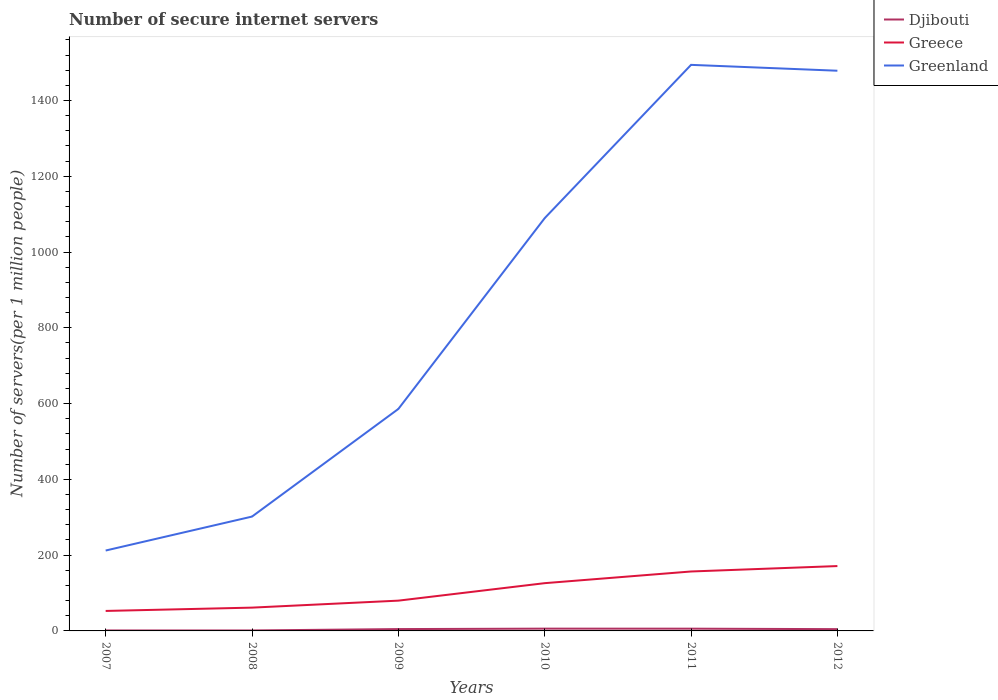Across all years, what is the maximum number of secure internet servers in Greenland?
Offer a very short reply. 212.18. What is the total number of secure internet servers in Greece in the graph?
Your answer should be very brief. -64.56. What is the difference between the highest and the second highest number of secure internet servers in Greece?
Provide a succinct answer. 118.43. What is the difference between the highest and the lowest number of secure internet servers in Greenland?
Your answer should be very brief. 3. Are the values on the major ticks of Y-axis written in scientific E-notation?
Give a very brief answer. No. How many legend labels are there?
Give a very brief answer. 3. How are the legend labels stacked?
Provide a short and direct response. Vertical. What is the title of the graph?
Provide a short and direct response. Number of secure internet servers. What is the label or title of the Y-axis?
Provide a short and direct response. Number of servers(per 1 million people). What is the Number of servers(per 1 million people) of Djibouti in 2007?
Your answer should be compact. 1.25. What is the Number of servers(per 1 million people) in Greece in 2007?
Your answer should be compact. 52.76. What is the Number of servers(per 1 million people) in Greenland in 2007?
Provide a succinct answer. 212.18. What is the Number of servers(per 1 million people) in Djibouti in 2008?
Make the answer very short. 1.24. What is the Number of servers(per 1 million people) in Greece in 2008?
Keep it short and to the point. 61.5. What is the Number of servers(per 1 million people) in Greenland in 2008?
Ensure brevity in your answer.  301.8. What is the Number of servers(per 1 million people) of Djibouti in 2009?
Give a very brief answer. 4.88. What is the Number of servers(per 1 million people) of Greece in 2009?
Keep it short and to the point. 79.91. What is the Number of servers(per 1 million people) in Greenland in 2009?
Offer a terse response. 585.91. What is the Number of servers(per 1 million people) of Djibouti in 2010?
Give a very brief answer. 6.02. What is the Number of servers(per 1 million people) in Greece in 2010?
Keep it short and to the point. 126.06. What is the Number of servers(per 1 million people) in Greenland in 2010?
Provide a short and direct response. 1089.54. What is the Number of servers(per 1 million people) in Djibouti in 2011?
Give a very brief answer. 5.94. What is the Number of servers(per 1 million people) in Greece in 2011?
Your response must be concise. 156.88. What is the Number of servers(per 1 million people) in Greenland in 2011?
Make the answer very short. 1494.11. What is the Number of servers(per 1 million people) in Djibouti in 2012?
Offer a very short reply. 4.69. What is the Number of servers(per 1 million people) of Greece in 2012?
Provide a succinct answer. 171.19. What is the Number of servers(per 1 million people) in Greenland in 2012?
Offer a very short reply. 1478.61. Across all years, what is the maximum Number of servers(per 1 million people) in Djibouti?
Offer a terse response. 6.02. Across all years, what is the maximum Number of servers(per 1 million people) of Greece?
Your answer should be compact. 171.19. Across all years, what is the maximum Number of servers(per 1 million people) of Greenland?
Provide a short and direct response. 1494.11. Across all years, what is the minimum Number of servers(per 1 million people) in Djibouti?
Your response must be concise. 1.24. Across all years, what is the minimum Number of servers(per 1 million people) in Greece?
Offer a terse response. 52.76. Across all years, what is the minimum Number of servers(per 1 million people) in Greenland?
Offer a terse response. 212.18. What is the total Number of servers(per 1 million people) in Djibouti in the graph?
Keep it short and to the point. 24.01. What is the total Number of servers(per 1 million people) in Greece in the graph?
Keep it short and to the point. 648.31. What is the total Number of servers(per 1 million people) in Greenland in the graph?
Keep it short and to the point. 5162.15. What is the difference between the Number of servers(per 1 million people) in Djibouti in 2007 and that in 2008?
Provide a short and direct response. 0.02. What is the difference between the Number of servers(per 1 million people) of Greece in 2007 and that in 2008?
Provide a succinct answer. -8.74. What is the difference between the Number of servers(per 1 million people) of Greenland in 2007 and that in 2008?
Your answer should be very brief. -89.62. What is the difference between the Number of servers(per 1 million people) in Djibouti in 2007 and that in 2009?
Your response must be concise. -3.63. What is the difference between the Number of servers(per 1 million people) of Greece in 2007 and that in 2009?
Provide a short and direct response. -27.15. What is the difference between the Number of servers(per 1 million people) of Greenland in 2007 and that in 2009?
Provide a succinct answer. -373.72. What is the difference between the Number of servers(per 1 million people) in Djibouti in 2007 and that in 2010?
Make the answer very short. -4.77. What is the difference between the Number of servers(per 1 million people) of Greece in 2007 and that in 2010?
Offer a terse response. -73.3. What is the difference between the Number of servers(per 1 million people) of Greenland in 2007 and that in 2010?
Your answer should be very brief. -877.35. What is the difference between the Number of servers(per 1 million people) in Djibouti in 2007 and that in 2011?
Offer a very short reply. -4.69. What is the difference between the Number of servers(per 1 million people) in Greece in 2007 and that in 2011?
Your answer should be compact. -104.12. What is the difference between the Number of servers(per 1 million people) of Greenland in 2007 and that in 2011?
Ensure brevity in your answer.  -1281.93. What is the difference between the Number of servers(per 1 million people) in Djibouti in 2007 and that in 2012?
Keep it short and to the point. -3.44. What is the difference between the Number of servers(per 1 million people) of Greece in 2007 and that in 2012?
Give a very brief answer. -118.43. What is the difference between the Number of servers(per 1 million people) of Greenland in 2007 and that in 2012?
Your response must be concise. -1266.43. What is the difference between the Number of servers(per 1 million people) in Djibouti in 2008 and that in 2009?
Your answer should be compact. -3.64. What is the difference between the Number of servers(per 1 million people) of Greece in 2008 and that in 2009?
Offer a terse response. -18.41. What is the difference between the Number of servers(per 1 million people) of Greenland in 2008 and that in 2009?
Your answer should be very brief. -284.1. What is the difference between the Number of servers(per 1 million people) of Djibouti in 2008 and that in 2010?
Your answer should be very brief. -4.78. What is the difference between the Number of servers(per 1 million people) in Greece in 2008 and that in 2010?
Your answer should be compact. -64.56. What is the difference between the Number of servers(per 1 million people) of Greenland in 2008 and that in 2010?
Offer a very short reply. -787.73. What is the difference between the Number of servers(per 1 million people) in Djibouti in 2008 and that in 2011?
Give a very brief answer. -4.7. What is the difference between the Number of servers(per 1 million people) of Greece in 2008 and that in 2011?
Offer a very short reply. -95.38. What is the difference between the Number of servers(per 1 million people) of Greenland in 2008 and that in 2011?
Provide a short and direct response. -1192.31. What is the difference between the Number of servers(per 1 million people) in Djibouti in 2008 and that in 2012?
Provide a short and direct response. -3.45. What is the difference between the Number of servers(per 1 million people) in Greece in 2008 and that in 2012?
Offer a terse response. -109.69. What is the difference between the Number of servers(per 1 million people) in Greenland in 2008 and that in 2012?
Ensure brevity in your answer.  -1176.81. What is the difference between the Number of servers(per 1 million people) in Djibouti in 2009 and that in 2010?
Ensure brevity in your answer.  -1.14. What is the difference between the Number of servers(per 1 million people) of Greece in 2009 and that in 2010?
Ensure brevity in your answer.  -46.15. What is the difference between the Number of servers(per 1 million people) of Greenland in 2009 and that in 2010?
Ensure brevity in your answer.  -503.63. What is the difference between the Number of servers(per 1 million people) in Djibouti in 2009 and that in 2011?
Offer a terse response. -1.06. What is the difference between the Number of servers(per 1 million people) in Greece in 2009 and that in 2011?
Your answer should be compact. -76.97. What is the difference between the Number of servers(per 1 million people) in Greenland in 2009 and that in 2011?
Make the answer very short. -908.21. What is the difference between the Number of servers(per 1 million people) in Djibouti in 2009 and that in 2012?
Make the answer very short. 0.19. What is the difference between the Number of servers(per 1 million people) of Greece in 2009 and that in 2012?
Your answer should be very brief. -91.28. What is the difference between the Number of servers(per 1 million people) of Greenland in 2009 and that in 2012?
Make the answer very short. -892.71. What is the difference between the Number of servers(per 1 million people) in Djibouti in 2010 and that in 2011?
Offer a very short reply. 0.08. What is the difference between the Number of servers(per 1 million people) of Greece in 2010 and that in 2011?
Your answer should be compact. -30.82. What is the difference between the Number of servers(per 1 million people) in Greenland in 2010 and that in 2011?
Provide a succinct answer. -404.58. What is the difference between the Number of servers(per 1 million people) of Djibouti in 2010 and that in 2012?
Give a very brief answer. 1.33. What is the difference between the Number of servers(per 1 million people) in Greece in 2010 and that in 2012?
Give a very brief answer. -45.13. What is the difference between the Number of servers(per 1 million people) of Greenland in 2010 and that in 2012?
Give a very brief answer. -389.08. What is the difference between the Number of servers(per 1 million people) in Djibouti in 2011 and that in 2012?
Ensure brevity in your answer.  1.25. What is the difference between the Number of servers(per 1 million people) in Greece in 2011 and that in 2012?
Your answer should be compact. -14.31. What is the difference between the Number of servers(per 1 million people) in Greenland in 2011 and that in 2012?
Provide a short and direct response. 15.5. What is the difference between the Number of servers(per 1 million people) in Djibouti in 2007 and the Number of servers(per 1 million people) in Greece in 2008?
Provide a short and direct response. -60.25. What is the difference between the Number of servers(per 1 million people) in Djibouti in 2007 and the Number of servers(per 1 million people) in Greenland in 2008?
Keep it short and to the point. -300.55. What is the difference between the Number of servers(per 1 million people) of Greece in 2007 and the Number of servers(per 1 million people) of Greenland in 2008?
Your answer should be compact. -249.04. What is the difference between the Number of servers(per 1 million people) of Djibouti in 2007 and the Number of servers(per 1 million people) of Greece in 2009?
Provide a short and direct response. -78.66. What is the difference between the Number of servers(per 1 million people) of Djibouti in 2007 and the Number of servers(per 1 million people) of Greenland in 2009?
Your answer should be very brief. -584.66. What is the difference between the Number of servers(per 1 million people) of Greece in 2007 and the Number of servers(per 1 million people) of Greenland in 2009?
Keep it short and to the point. -533.14. What is the difference between the Number of servers(per 1 million people) in Djibouti in 2007 and the Number of servers(per 1 million people) in Greece in 2010?
Your response must be concise. -124.81. What is the difference between the Number of servers(per 1 million people) of Djibouti in 2007 and the Number of servers(per 1 million people) of Greenland in 2010?
Provide a short and direct response. -1088.28. What is the difference between the Number of servers(per 1 million people) in Greece in 2007 and the Number of servers(per 1 million people) in Greenland in 2010?
Provide a succinct answer. -1036.77. What is the difference between the Number of servers(per 1 million people) of Djibouti in 2007 and the Number of servers(per 1 million people) of Greece in 2011?
Keep it short and to the point. -155.63. What is the difference between the Number of servers(per 1 million people) of Djibouti in 2007 and the Number of servers(per 1 million people) of Greenland in 2011?
Keep it short and to the point. -1492.86. What is the difference between the Number of servers(per 1 million people) in Greece in 2007 and the Number of servers(per 1 million people) in Greenland in 2011?
Offer a very short reply. -1441.35. What is the difference between the Number of servers(per 1 million people) in Djibouti in 2007 and the Number of servers(per 1 million people) in Greece in 2012?
Offer a very short reply. -169.94. What is the difference between the Number of servers(per 1 million people) of Djibouti in 2007 and the Number of servers(per 1 million people) of Greenland in 2012?
Provide a succinct answer. -1477.36. What is the difference between the Number of servers(per 1 million people) of Greece in 2007 and the Number of servers(per 1 million people) of Greenland in 2012?
Keep it short and to the point. -1425.85. What is the difference between the Number of servers(per 1 million people) in Djibouti in 2008 and the Number of servers(per 1 million people) in Greece in 2009?
Make the answer very short. -78.68. What is the difference between the Number of servers(per 1 million people) in Djibouti in 2008 and the Number of servers(per 1 million people) in Greenland in 2009?
Provide a short and direct response. -584.67. What is the difference between the Number of servers(per 1 million people) of Greece in 2008 and the Number of servers(per 1 million people) of Greenland in 2009?
Ensure brevity in your answer.  -524.4. What is the difference between the Number of servers(per 1 million people) in Djibouti in 2008 and the Number of servers(per 1 million people) in Greece in 2010?
Ensure brevity in your answer.  -124.82. What is the difference between the Number of servers(per 1 million people) of Djibouti in 2008 and the Number of servers(per 1 million people) of Greenland in 2010?
Make the answer very short. -1088.3. What is the difference between the Number of servers(per 1 million people) of Greece in 2008 and the Number of servers(per 1 million people) of Greenland in 2010?
Your answer should be compact. -1028.03. What is the difference between the Number of servers(per 1 million people) in Djibouti in 2008 and the Number of servers(per 1 million people) in Greece in 2011?
Offer a terse response. -155.64. What is the difference between the Number of servers(per 1 million people) of Djibouti in 2008 and the Number of servers(per 1 million people) of Greenland in 2011?
Keep it short and to the point. -1492.88. What is the difference between the Number of servers(per 1 million people) in Greece in 2008 and the Number of servers(per 1 million people) in Greenland in 2011?
Your response must be concise. -1432.61. What is the difference between the Number of servers(per 1 million people) of Djibouti in 2008 and the Number of servers(per 1 million people) of Greece in 2012?
Your response must be concise. -169.96. What is the difference between the Number of servers(per 1 million people) in Djibouti in 2008 and the Number of servers(per 1 million people) in Greenland in 2012?
Make the answer very short. -1477.38. What is the difference between the Number of servers(per 1 million people) of Greece in 2008 and the Number of servers(per 1 million people) of Greenland in 2012?
Keep it short and to the point. -1417.11. What is the difference between the Number of servers(per 1 million people) in Djibouti in 2009 and the Number of servers(per 1 million people) in Greece in 2010?
Ensure brevity in your answer.  -121.18. What is the difference between the Number of servers(per 1 million people) of Djibouti in 2009 and the Number of servers(per 1 million people) of Greenland in 2010?
Give a very brief answer. -1084.66. What is the difference between the Number of servers(per 1 million people) of Greece in 2009 and the Number of servers(per 1 million people) of Greenland in 2010?
Make the answer very short. -1009.62. What is the difference between the Number of servers(per 1 million people) of Djibouti in 2009 and the Number of servers(per 1 million people) of Greece in 2011?
Provide a succinct answer. -152. What is the difference between the Number of servers(per 1 million people) of Djibouti in 2009 and the Number of servers(per 1 million people) of Greenland in 2011?
Provide a short and direct response. -1489.23. What is the difference between the Number of servers(per 1 million people) of Greece in 2009 and the Number of servers(per 1 million people) of Greenland in 2011?
Ensure brevity in your answer.  -1414.2. What is the difference between the Number of servers(per 1 million people) of Djibouti in 2009 and the Number of servers(per 1 million people) of Greece in 2012?
Make the answer very short. -166.32. What is the difference between the Number of servers(per 1 million people) in Djibouti in 2009 and the Number of servers(per 1 million people) in Greenland in 2012?
Offer a very short reply. -1473.74. What is the difference between the Number of servers(per 1 million people) of Greece in 2009 and the Number of servers(per 1 million people) of Greenland in 2012?
Offer a very short reply. -1398.7. What is the difference between the Number of servers(per 1 million people) in Djibouti in 2010 and the Number of servers(per 1 million people) in Greece in 2011?
Provide a short and direct response. -150.86. What is the difference between the Number of servers(per 1 million people) of Djibouti in 2010 and the Number of servers(per 1 million people) of Greenland in 2011?
Offer a very short reply. -1488.09. What is the difference between the Number of servers(per 1 million people) in Greece in 2010 and the Number of servers(per 1 million people) in Greenland in 2011?
Your answer should be compact. -1368.05. What is the difference between the Number of servers(per 1 million people) of Djibouti in 2010 and the Number of servers(per 1 million people) of Greece in 2012?
Provide a short and direct response. -165.17. What is the difference between the Number of servers(per 1 million people) in Djibouti in 2010 and the Number of servers(per 1 million people) in Greenland in 2012?
Your answer should be compact. -1472.59. What is the difference between the Number of servers(per 1 million people) of Greece in 2010 and the Number of servers(per 1 million people) of Greenland in 2012?
Your answer should be compact. -1352.55. What is the difference between the Number of servers(per 1 million people) in Djibouti in 2011 and the Number of servers(per 1 million people) in Greece in 2012?
Offer a very short reply. -165.25. What is the difference between the Number of servers(per 1 million people) of Djibouti in 2011 and the Number of servers(per 1 million people) of Greenland in 2012?
Provide a succinct answer. -1472.67. What is the difference between the Number of servers(per 1 million people) of Greece in 2011 and the Number of servers(per 1 million people) of Greenland in 2012?
Provide a short and direct response. -1321.73. What is the average Number of servers(per 1 million people) in Djibouti per year?
Your answer should be very brief. 4. What is the average Number of servers(per 1 million people) of Greece per year?
Provide a succinct answer. 108.05. What is the average Number of servers(per 1 million people) in Greenland per year?
Provide a short and direct response. 860.36. In the year 2007, what is the difference between the Number of servers(per 1 million people) of Djibouti and Number of servers(per 1 million people) of Greece?
Provide a succinct answer. -51.51. In the year 2007, what is the difference between the Number of servers(per 1 million people) in Djibouti and Number of servers(per 1 million people) in Greenland?
Your answer should be very brief. -210.93. In the year 2007, what is the difference between the Number of servers(per 1 million people) of Greece and Number of servers(per 1 million people) of Greenland?
Your answer should be very brief. -159.42. In the year 2008, what is the difference between the Number of servers(per 1 million people) of Djibouti and Number of servers(per 1 million people) of Greece?
Provide a short and direct response. -60.27. In the year 2008, what is the difference between the Number of servers(per 1 million people) in Djibouti and Number of servers(per 1 million people) in Greenland?
Offer a terse response. -300.57. In the year 2008, what is the difference between the Number of servers(per 1 million people) in Greece and Number of servers(per 1 million people) in Greenland?
Your response must be concise. -240.3. In the year 2009, what is the difference between the Number of servers(per 1 million people) in Djibouti and Number of servers(per 1 million people) in Greece?
Your answer should be compact. -75.04. In the year 2009, what is the difference between the Number of servers(per 1 million people) of Djibouti and Number of servers(per 1 million people) of Greenland?
Your response must be concise. -581.03. In the year 2009, what is the difference between the Number of servers(per 1 million people) of Greece and Number of servers(per 1 million people) of Greenland?
Provide a succinct answer. -505.99. In the year 2010, what is the difference between the Number of servers(per 1 million people) in Djibouti and Number of servers(per 1 million people) in Greece?
Make the answer very short. -120.04. In the year 2010, what is the difference between the Number of servers(per 1 million people) of Djibouti and Number of servers(per 1 million people) of Greenland?
Provide a short and direct response. -1083.52. In the year 2010, what is the difference between the Number of servers(per 1 million people) of Greece and Number of servers(per 1 million people) of Greenland?
Offer a very short reply. -963.48. In the year 2011, what is the difference between the Number of servers(per 1 million people) of Djibouti and Number of servers(per 1 million people) of Greece?
Your response must be concise. -150.94. In the year 2011, what is the difference between the Number of servers(per 1 million people) in Djibouti and Number of servers(per 1 million people) in Greenland?
Provide a short and direct response. -1488.17. In the year 2011, what is the difference between the Number of servers(per 1 million people) in Greece and Number of servers(per 1 million people) in Greenland?
Ensure brevity in your answer.  -1337.23. In the year 2012, what is the difference between the Number of servers(per 1 million people) in Djibouti and Number of servers(per 1 million people) in Greece?
Offer a very short reply. -166.5. In the year 2012, what is the difference between the Number of servers(per 1 million people) in Djibouti and Number of servers(per 1 million people) in Greenland?
Your response must be concise. -1473.92. In the year 2012, what is the difference between the Number of servers(per 1 million people) in Greece and Number of servers(per 1 million people) in Greenland?
Ensure brevity in your answer.  -1307.42. What is the ratio of the Number of servers(per 1 million people) in Djibouti in 2007 to that in 2008?
Give a very brief answer. 1.01. What is the ratio of the Number of servers(per 1 million people) in Greece in 2007 to that in 2008?
Your answer should be compact. 0.86. What is the ratio of the Number of servers(per 1 million people) in Greenland in 2007 to that in 2008?
Provide a short and direct response. 0.7. What is the ratio of the Number of servers(per 1 million people) of Djibouti in 2007 to that in 2009?
Your response must be concise. 0.26. What is the ratio of the Number of servers(per 1 million people) of Greece in 2007 to that in 2009?
Your answer should be compact. 0.66. What is the ratio of the Number of servers(per 1 million people) in Greenland in 2007 to that in 2009?
Offer a terse response. 0.36. What is the ratio of the Number of servers(per 1 million people) in Djibouti in 2007 to that in 2010?
Offer a terse response. 0.21. What is the ratio of the Number of servers(per 1 million people) in Greece in 2007 to that in 2010?
Your answer should be very brief. 0.42. What is the ratio of the Number of servers(per 1 million people) in Greenland in 2007 to that in 2010?
Provide a succinct answer. 0.19. What is the ratio of the Number of servers(per 1 million people) of Djibouti in 2007 to that in 2011?
Your response must be concise. 0.21. What is the ratio of the Number of servers(per 1 million people) in Greece in 2007 to that in 2011?
Offer a terse response. 0.34. What is the ratio of the Number of servers(per 1 million people) of Greenland in 2007 to that in 2011?
Offer a terse response. 0.14. What is the ratio of the Number of servers(per 1 million people) in Djibouti in 2007 to that in 2012?
Your response must be concise. 0.27. What is the ratio of the Number of servers(per 1 million people) of Greece in 2007 to that in 2012?
Make the answer very short. 0.31. What is the ratio of the Number of servers(per 1 million people) in Greenland in 2007 to that in 2012?
Offer a terse response. 0.14. What is the ratio of the Number of servers(per 1 million people) of Djibouti in 2008 to that in 2009?
Make the answer very short. 0.25. What is the ratio of the Number of servers(per 1 million people) in Greece in 2008 to that in 2009?
Keep it short and to the point. 0.77. What is the ratio of the Number of servers(per 1 million people) of Greenland in 2008 to that in 2009?
Make the answer very short. 0.52. What is the ratio of the Number of servers(per 1 million people) in Djibouti in 2008 to that in 2010?
Make the answer very short. 0.21. What is the ratio of the Number of servers(per 1 million people) in Greece in 2008 to that in 2010?
Make the answer very short. 0.49. What is the ratio of the Number of servers(per 1 million people) in Greenland in 2008 to that in 2010?
Offer a very short reply. 0.28. What is the ratio of the Number of servers(per 1 million people) of Djibouti in 2008 to that in 2011?
Your answer should be compact. 0.21. What is the ratio of the Number of servers(per 1 million people) in Greece in 2008 to that in 2011?
Ensure brevity in your answer.  0.39. What is the ratio of the Number of servers(per 1 million people) in Greenland in 2008 to that in 2011?
Your response must be concise. 0.2. What is the ratio of the Number of servers(per 1 million people) of Djibouti in 2008 to that in 2012?
Your answer should be compact. 0.26. What is the ratio of the Number of servers(per 1 million people) in Greece in 2008 to that in 2012?
Give a very brief answer. 0.36. What is the ratio of the Number of servers(per 1 million people) of Greenland in 2008 to that in 2012?
Offer a very short reply. 0.2. What is the ratio of the Number of servers(per 1 million people) of Djibouti in 2009 to that in 2010?
Keep it short and to the point. 0.81. What is the ratio of the Number of servers(per 1 million people) in Greece in 2009 to that in 2010?
Keep it short and to the point. 0.63. What is the ratio of the Number of servers(per 1 million people) in Greenland in 2009 to that in 2010?
Ensure brevity in your answer.  0.54. What is the ratio of the Number of servers(per 1 million people) of Djibouti in 2009 to that in 2011?
Give a very brief answer. 0.82. What is the ratio of the Number of servers(per 1 million people) of Greece in 2009 to that in 2011?
Offer a terse response. 0.51. What is the ratio of the Number of servers(per 1 million people) of Greenland in 2009 to that in 2011?
Provide a short and direct response. 0.39. What is the ratio of the Number of servers(per 1 million people) in Djibouti in 2009 to that in 2012?
Provide a short and direct response. 1.04. What is the ratio of the Number of servers(per 1 million people) in Greece in 2009 to that in 2012?
Offer a terse response. 0.47. What is the ratio of the Number of servers(per 1 million people) of Greenland in 2009 to that in 2012?
Your response must be concise. 0.4. What is the ratio of the Number of servers(per 1 million people) of Djibouti in 2010 to that in 2011?
Offer a very short reply. 1.01. What is the ratio of the Number of servers(per 1 million people) of Greece in 2010 to that in 2011?
Make the answer very short. 0.8. What is the ratio of the Number of servers(per 1 million people) of Greenland in 2010 to that in 2011?
Provide a succinct answer. 0.73. What is the ratio of the Number of servers(per 1 million people) of Djibouti in 2010 to that in 2012?
Provide a short and direct response. 1.28. What is the ratio of the Number of servers(per 1 million people) in Greece in 2010 to that in 2012?
Offer a very short reply. 0.74. What is the ratio of the Number of servers(per 1 million people) in Greenland in 2010 to that in 2012?
Keep it short and to the point. 0.74. What is the ratio of the Number of servers(per 1 million people) of Djibouti in 2011 to that in 2012?
Provide a short and direct response. 1.27. What is the ratio of the Number of servers(per 1 million people) of Greece in 2011 to that in 2012?
Offer a terse response. 0.92. What is the ratio of the Number of servers(per 1 million people) in Greenland in 2011 to that in 2012?
Your answer should be compact. 1.01. What is the difference between the highest and the second highest Number of servers(per 1 million people) in Djibouti?
Make the answer very short. 0.08. What is the difference between the highest and the second highest Number of servers(per 1 million people) in Greece?
Offer a very short reply. 14.31. What is the difference between the highest and the second highest Number of servers(per 1 million people) of Greenland?
Your answer should be very brief. 15.5. What is the difference between the highest and the lowest Number of servers(per 1 million people) in Djibouti?
Make the answer very short. 4.78. What is the difference between the highest and the lowest Number of servers(per 1 million people) of Greece?
Give a very brief answer. 118.43. What is the difference between the highest and the lowest Number of servers(per 1 million people) of Greenland?
Keep it short and to the point. 1281.93. 